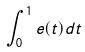Convert formula to latex. <formula><loc_0><loc_0><loc_500><loc_500>\int _ { 0 } ^ { 1 } e ( t ) d t</formula> 